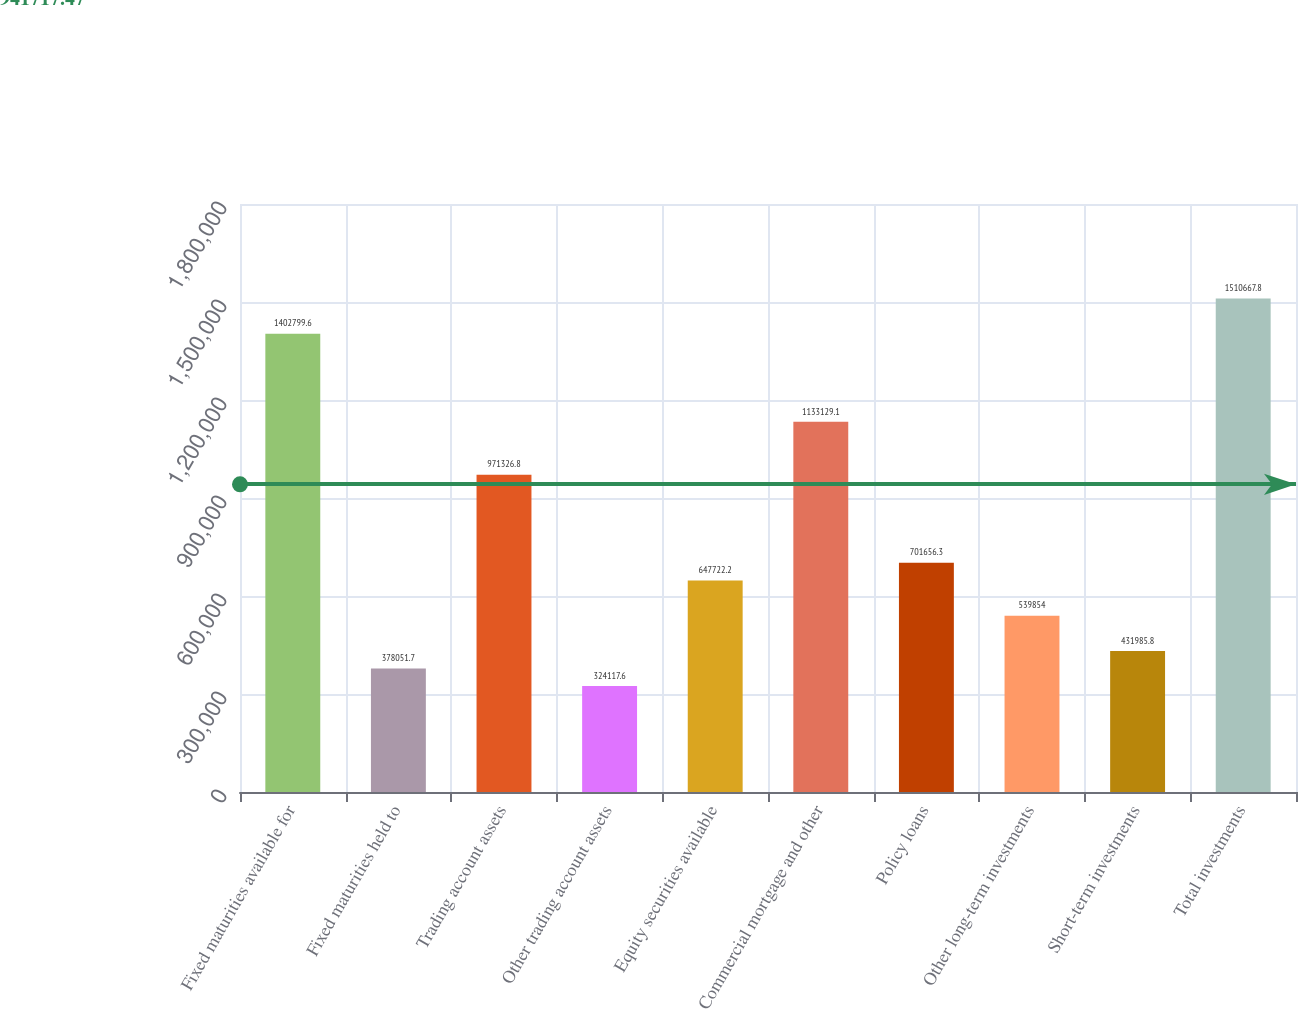Convert chart. <chart><loc_0><loc_0><loc_500><loc_500><bar_chart><fcel>Fixed maturities available for<fcel>Fixed maturities held to<fcel>Trading account assets<fcel>Other trading account assets<fcel>Equity securities available<fcel>Commercial mortgage and other<fcel>Policy loans<fcel>Other long-term investments<fcel>Short-term investments<fcel>Total investments<nl><fcel>1.4028e+06<fcel>378052<fcel>971327<fcel>324118<fcel>647722<fcel>1.13313e+06<fcel>701656<fcel>539854<fcel>431986<fcel>1.51067e+06<nl></chart> 